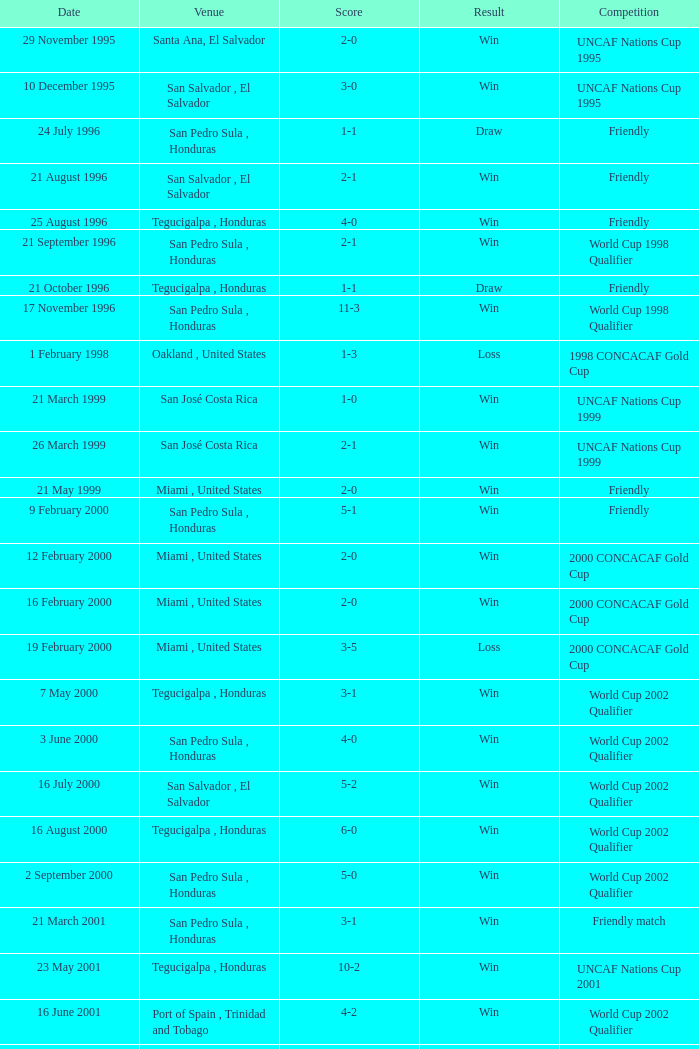What is the date of the uncaf nations cup 2009? 26 January 2009. 